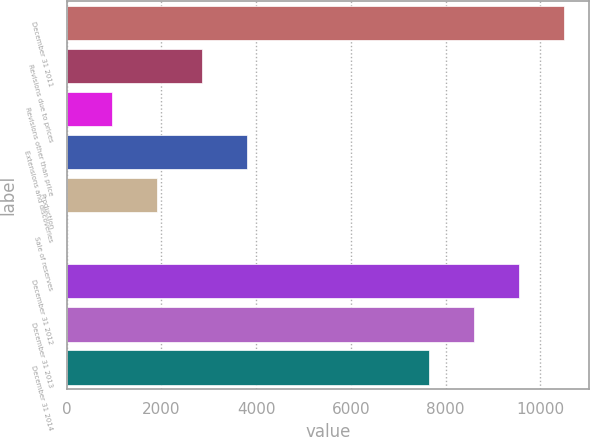<chart> <loc_0><loc_0><loc_500><loc_500><bar_chart><fcel>December 31 2011<fcel>Revisions due to prices<fcel>Revisions other than price<fcel>Extensions and discoveries<fcel>Production<fcel>Sale of reserves<fcel>December 31 2012<fcel>December 31 2013<fcel>December 31 2014<nl><fcel>10502.8<fcel>2852.8<fcel>951.6<fcel>3803.4<fcel>1902.2<fcel>1<fcel>9552.2<fcel>8601.6<fcel>7651<nl></chart> 